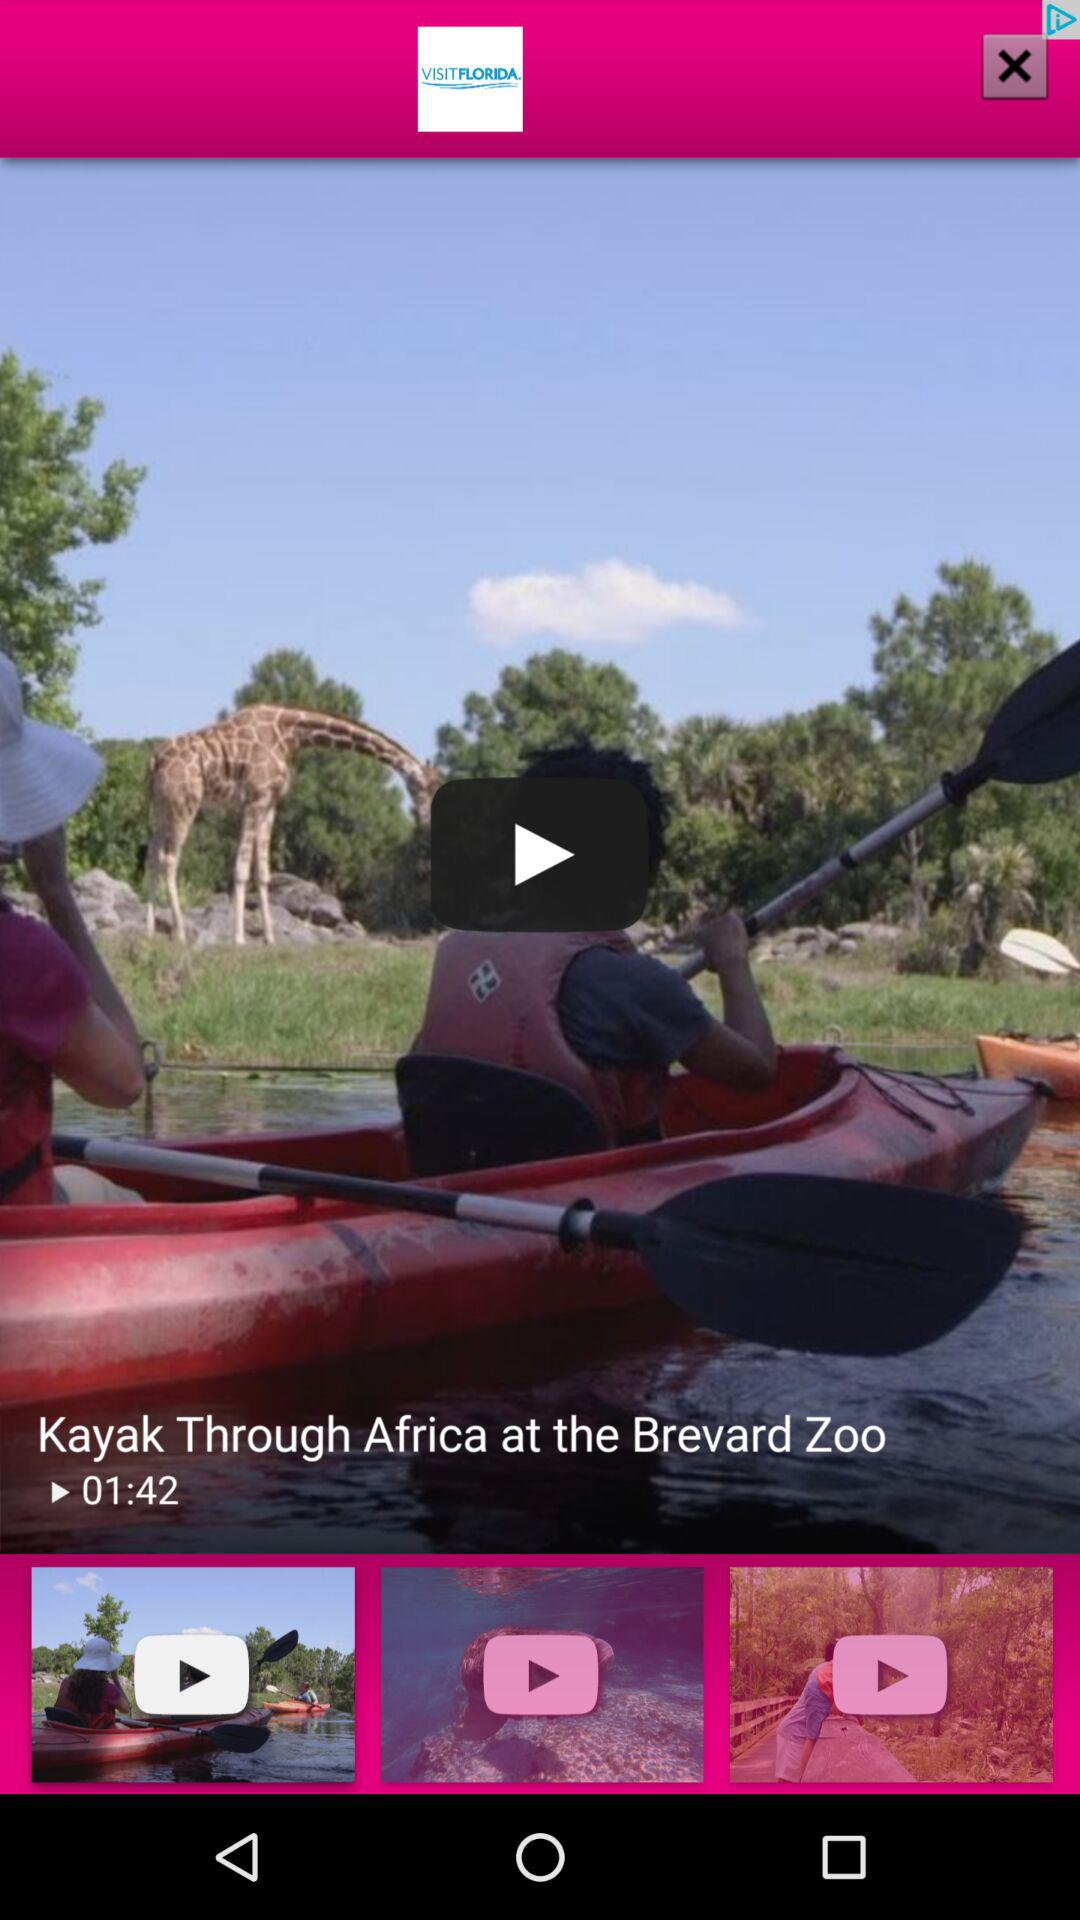What is the length of the video? The length of the video is 01:42. 